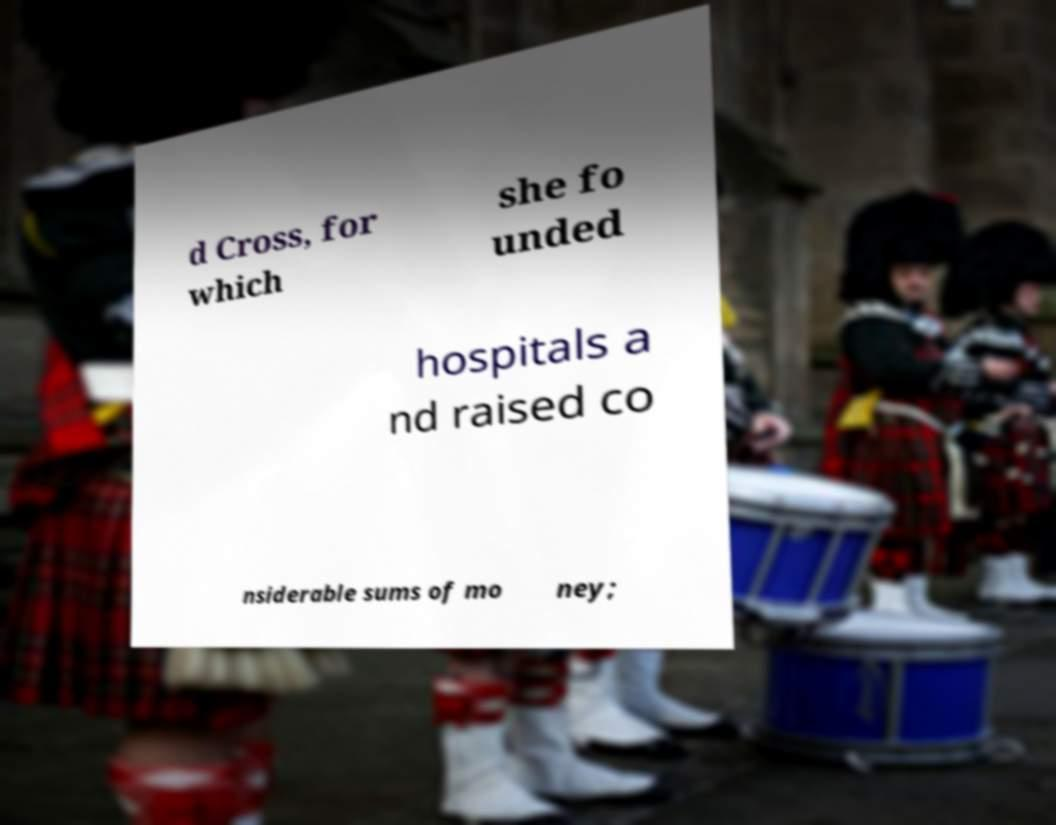I need the written content from this picture converted into text. Can you do that? d Cross, for which she fo unded hospitals a nd raised co nsiderable sums of mo ney; 